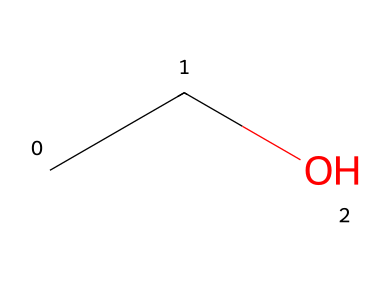What is the molecular formula for this compound? The SMILES representation "CCO" indicates the presence of two carbon (C) atoms and six hydrogen (H) atoms and one oxygen (O) atom. Therefore, the molecular formula is determined by counting these elements.
Answer: C2H6O How many hydrogen atoms are in ethanol? The SMILES notation "CCO" reveals that there are six hydrogen (H) atoms in the structure, as each carbon typically bonds with enough hydrogens to fulfill its tetravalent nature, and the oxygen is bonded to one carbon atom.
Answer: 6 What type of functional group does ethanol contain? The presence of the "O" in the SMILES notation indicates the presence of a hydroxyl (-OH) group, which is a characteristic functional group of alcohols. This group defines the compound as an alcohol.
Answer: hydroxyl Is ethanol a saturated or unsaturated hydrocarbon? This compound has only single bonds between carbon atoms, as seen in the SMILES representation. Saturated hydrocarbons are characterized by having all single bonds, thus governing its classification as saturated.
Answer: saturated What is the main role of ethanol in hair spray? Ethanol is primarily used in hair spray as a solvent and to help the product dry quickly after application. Its effectiveness relates to its volatility and solvency for other ingredients in the formulation.
Answer: solvent How many bonds are there in the ethanol molecule? The structure represented by "CCO" indicates there are a total of 5 bonds: 1 bond between the two carbons (C-C), 2 bonds from each carbon to three hydrogens (C-H), and 1 bond between the carbon and the oxygen (C-O). This gives a total of 5 bonds in the molecule.
Answer: 5 